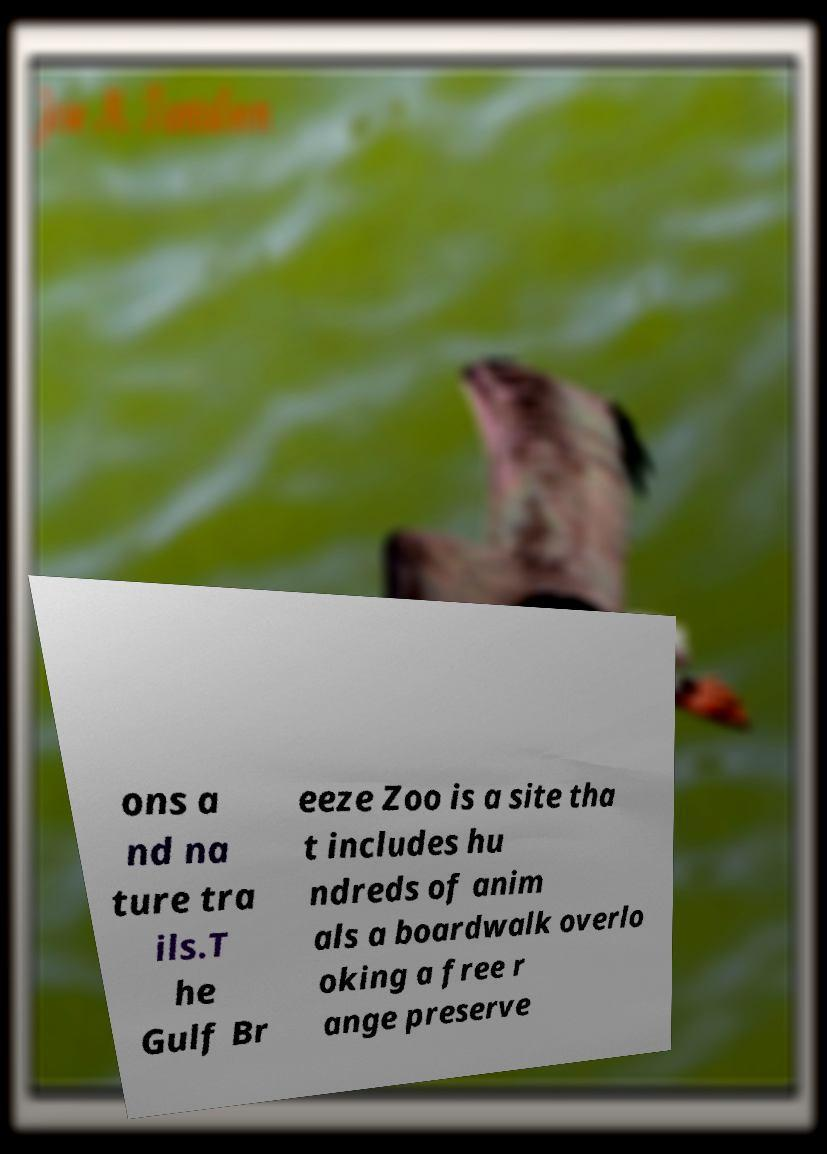For documentation purposes, I need the text within this image transcribed. Could you provide that? ons a nd na ture tra ils.T he Gulf Br eeze Zoo is a site tha t includes hu ndreds of anim als a boardwalk overlo oking a free r ange preserve 